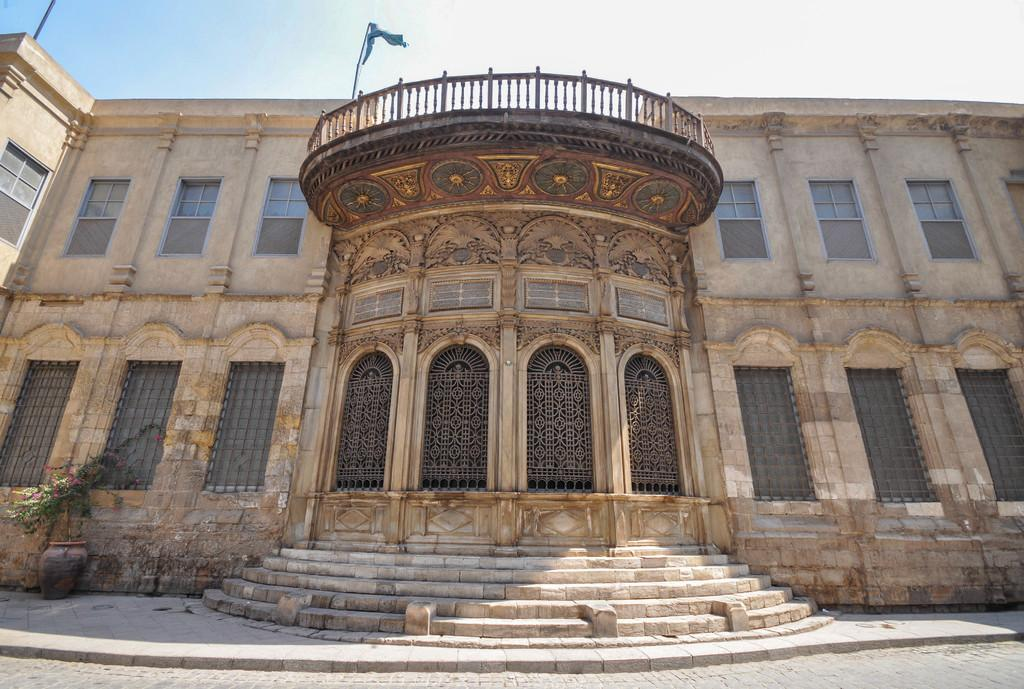What type of structure is visible in the image? There is a building in the image. What can be seen on the left side of the image? There is a plant on the left side of the image. What type of party is being held in the building in the image? There is no indication of a party being held in the building in the image. 